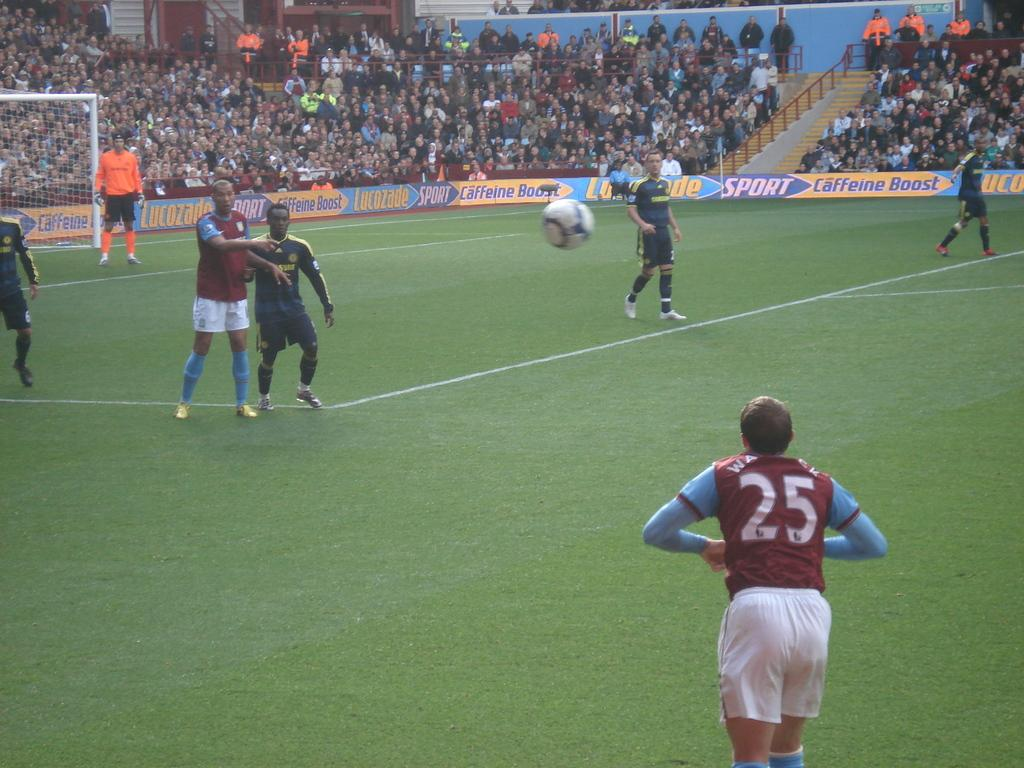<image>
Summarize the visual content of the image. A man wearing the number 25 soccer jersey is waiting for the ball. 